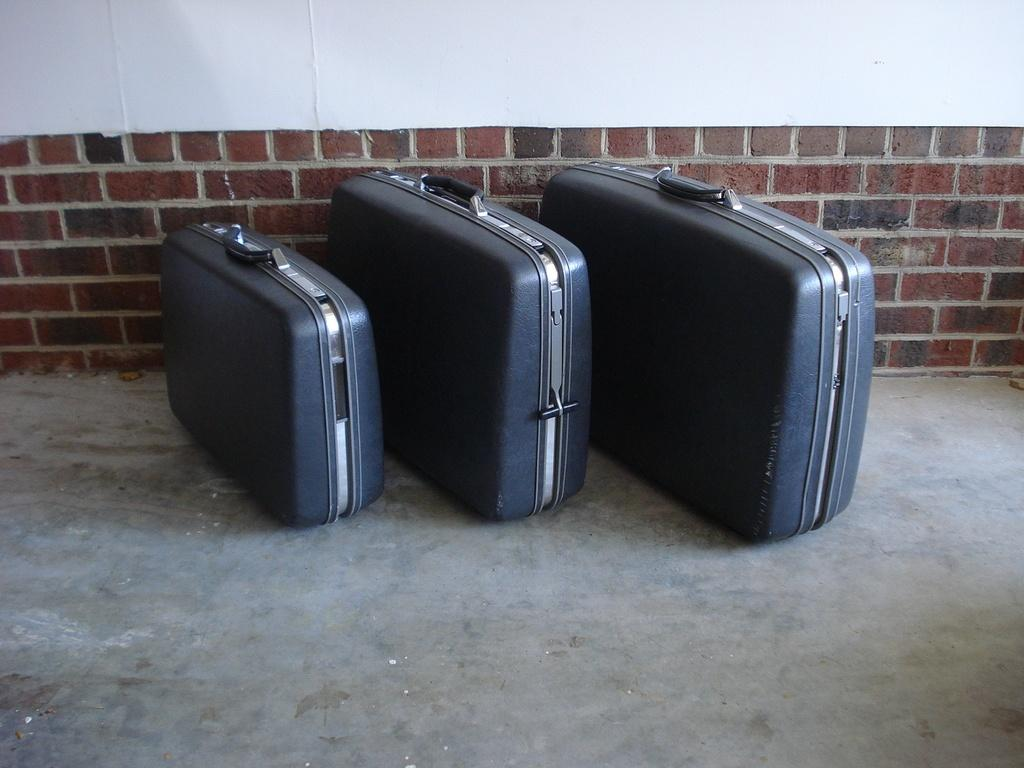How many suitcases are visible in the image? There are three suitcases in the image. Are the suitcases similar in size or different? The suitcases are of different sizes. What can be seen in the background of the image? There is a brick wall in the background of the image. What type of education is being discussed in the image? There is no discussion of education in the image; it features three suitcases and a brick wall in the background. 